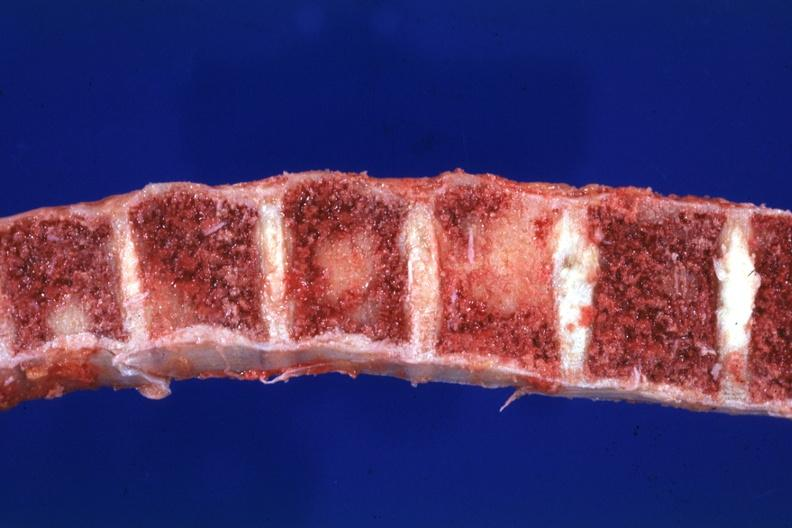s aorta not present?
Answer the question using a single word or phrase. No 